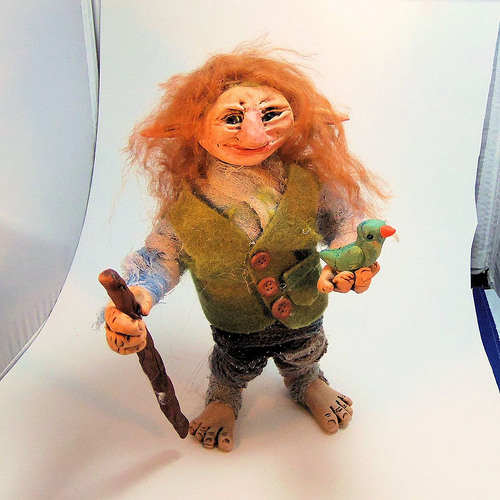<image>
Can you confirm if the troll is on the bird? No. The troll is not positioned on the bird. They may be near each other, but the troll is not supported by or resting on top of the bird. Is the doll above the stick? No. The doll is not positioned above the stick. The vertical arrangement shows a different relationship. 